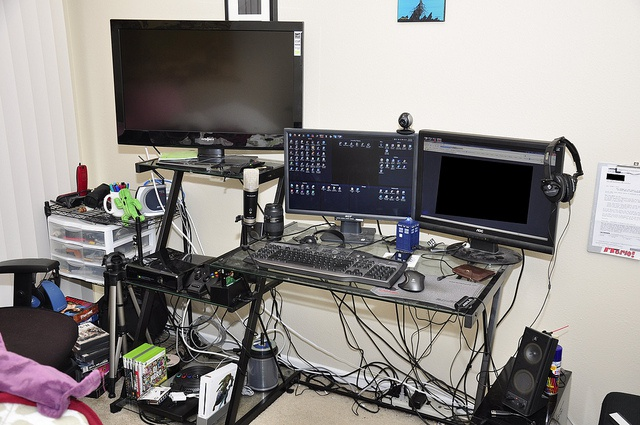Describe the objects in this image and their specific colors. I can see tv in lightgray, black, and gray tones, tv in lightgray, black, darkgray, and gray tones, tv in lightgray, black, gray, and darkgray tones, chair in lightgray, black, gray, and darkgray tones, and keyboard in lightgray, gray, black, and darkgray tones in this image. 